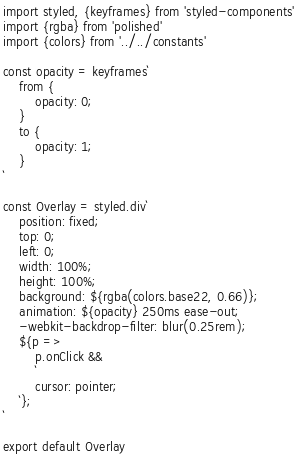<code> <loc_0><loc_0><loc_500><loc_500><_JavaScript_>import styled, {keyframes} from 'styled-components'
import {rgba} from 'polished'
import {colors} from '../../constants'

const opacity = keyframes`
	from {
		opacity: 0;
	}
	to {
		opacity: 1;
	}
`

const Overlay = styled.div`
	position: fixed;
	top: 0;
	left: 0;
	width: 100%;
	height: 100%;
	background: ${rgba(colors.base22, 0.66)};
	animation: ${opacity} 250ms ease-out;
	-webkit-backdrop-filter: blur(0.25rem);
	${p =>
		p.onClick &&
		`
		cursor: pointer;
	`};
`

export default Overlay
</code> 